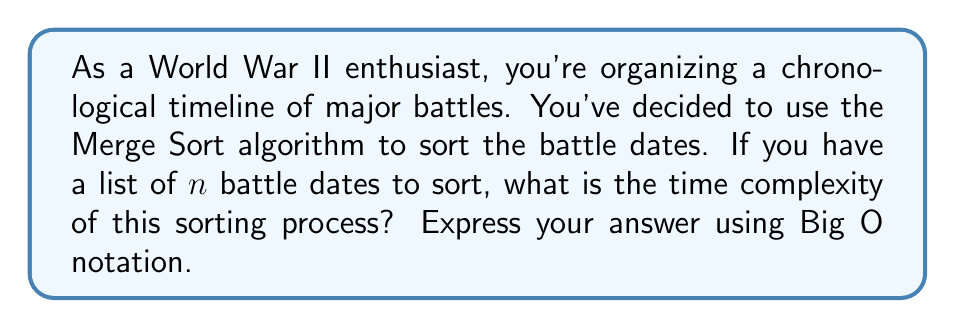Give your solution to this math problem. To analyze the time complexity of Merge Sort for sorting World War II battle dates, let's break down the algorithm:

1. Merge Sort is a divide-and-conquer algorithm that recursively divides the list into halves until we have individual elements.

2. The division process can be represented as a binary tree with $\log_2 n$ levels, where $n$ is the number of battle dates.

3. At each level, we perform a merging operation that compares and combines the sorted sublists.

4. The merging operation at each level processes all $n$ elements.

5. Therefore, at each level, we perform $O(n)$ operations.

6. Since we have $\log_2 n$ levels, and each level requires $O(n)$ operations, the total time complexity is:

   $$O(n \log n)$$

This time complexity holds for the best, average, and worst-case scenarios, making Merge Sort a consistent and efficient choice for sorting your World War II battle dates.

To put this in historical context, if you were sorting the dates of all major battles in World War II (let's say approximately 100 significant battles), the algorithm would perform roughly:

$$100 \times \log_2 100 \approx 664$$ 

operations, which is significantly more efficient than the $100^2 = 10,000$ comparisons that might be needed in a simpler sorting algorithm like Bubble Sort.
Answer: $O(n \log n)$ 